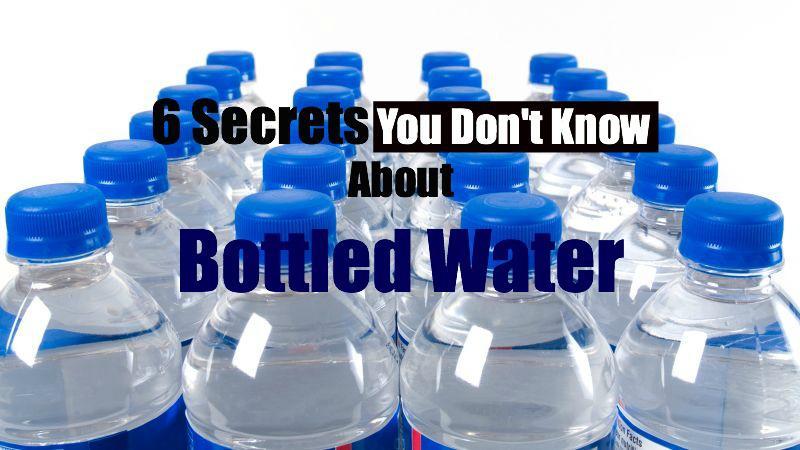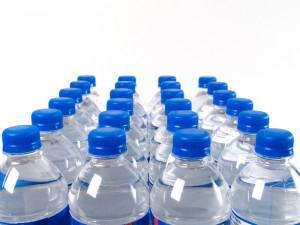The first image is the image on the left, the second image is the image on the right. Assess this claim about the two images: "Some of the containers don't have blue caps.". Correct or not? Answer yes or no. No. The first image is the image on the left, the second image is the image on the right. Given the left and right images, does the statement "There is exactly one water bottle in the image on the left." hold true? Answer yes or no. No. 